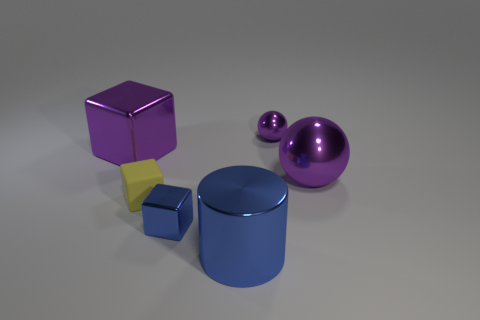Add 4 tiny purple metallic spheres. How many objects exist? 10 Subtract all cylinders. How many objects are left? 5 Add 5 cubes. How many cubes are left? 8 Add 3 large purple metal cylinders. How many large purple metal cylinders exist? 3 Subtract 0 brown spheres. How many objects are left? 6 Subtract all big things. Subtract all large purple metal blocks. How many objects are left? 2 